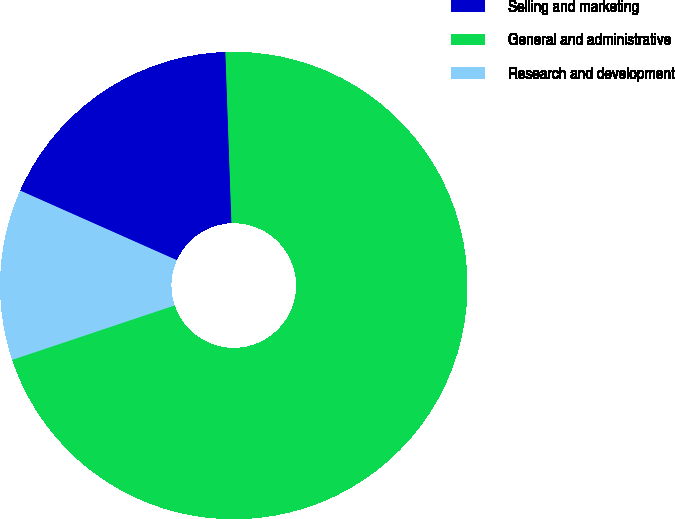<chart> <loc_0><loc_0><loc_500><loc_500><pie_chart><fcel>Selling and marketing<fcel>General and administrative<fcel>Research and development<nl><fcel>17.78%<fcel>70.42%<fcel>11.8%<nl></chart> 